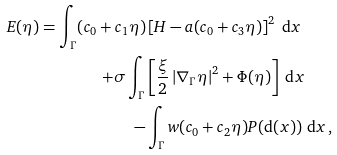<formula> <loc_0><loc_0><loc_500><loc_500>E ( \eta ) = \int _ { \Gamma } ( c _ { 0 } + c _ { 1 } \eta ) & \left [ H - a ( c _ { 0 } + c _ { 3 } \eta ) \right ] ^ { 2 } \ \text {d} x \\ + \sigma \int _ { \Gamma } & \left [ \frac { \xi } { 2 } \left | \nabla _ { \Gamma } \eta \right | ^ { 2 } + \Phi ( \eta ) \right ] \ \text {d} x \\ - & \int _ { \Gamma } w ( c _ { 0 } + c _ { 2 } \eta ) P ( \text {d} ( x ) ) \ \text {d} x \, ,</formula> 